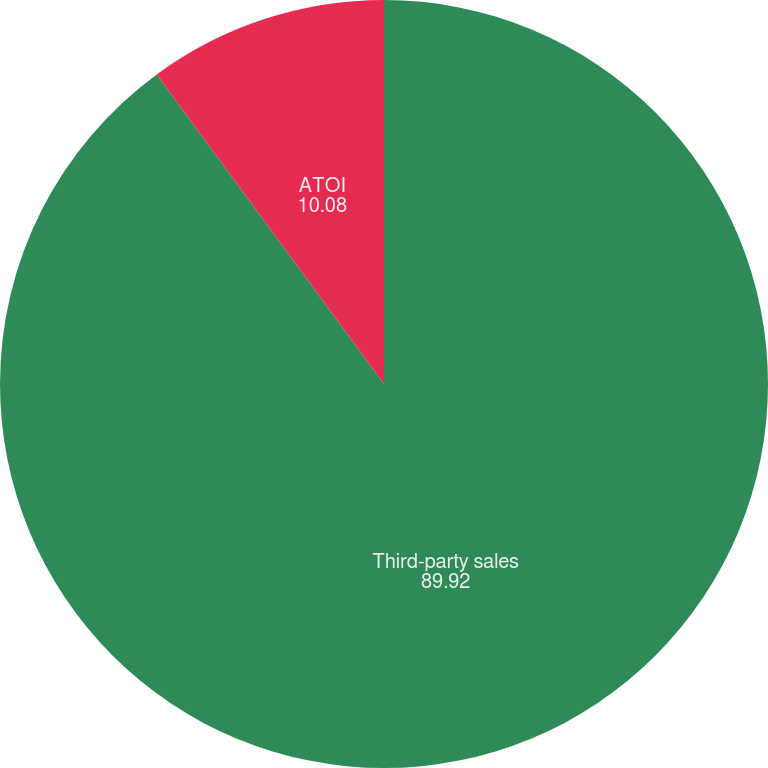Convert chart to OTSL. <chart><loc_0><loc_0><loc_500><loc_500><pie_chart><fcel>Third-party sales<fcel>ATOI<nl><fcel>89.92%<fcel>10.08%<nl></chart> 